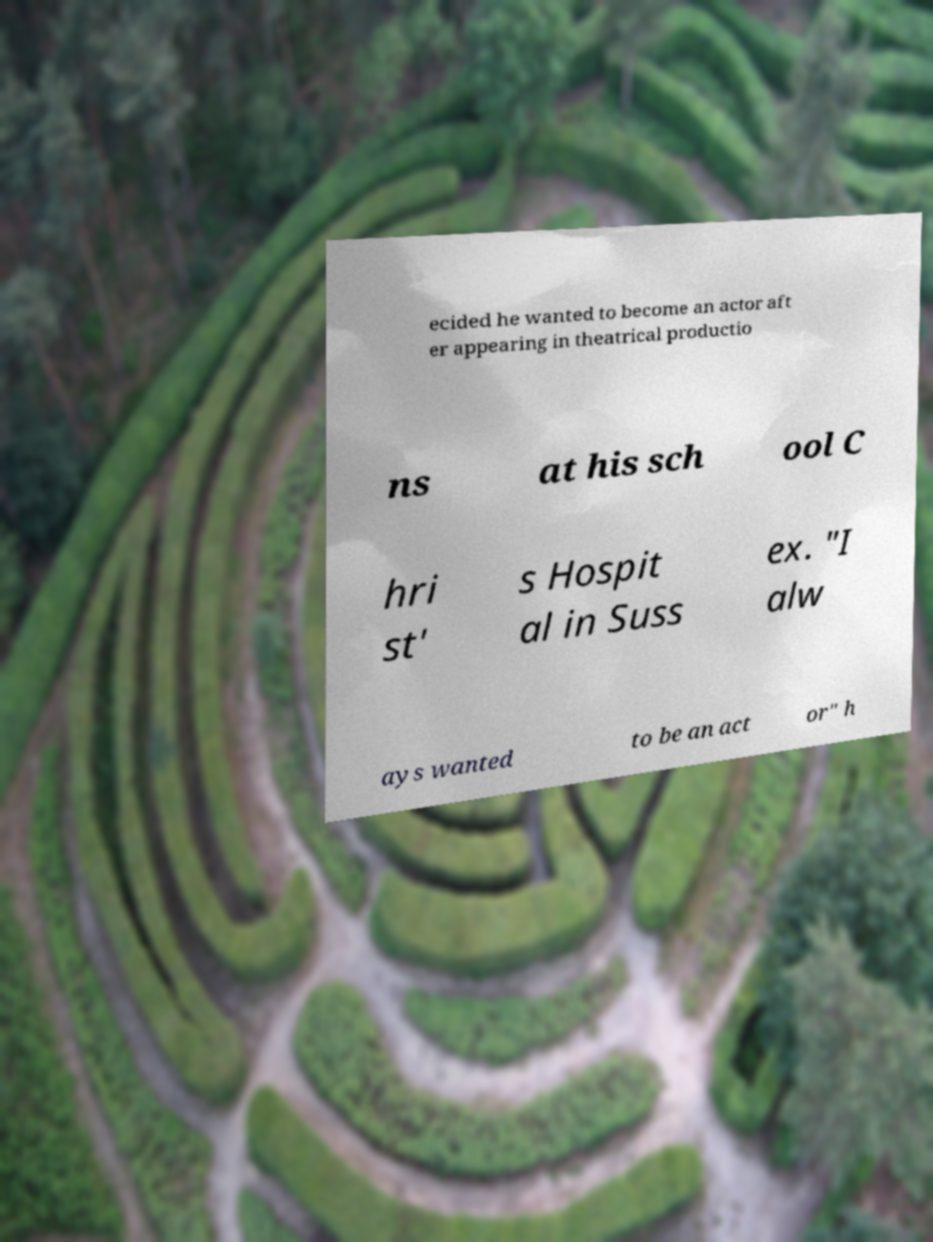Could you assist in decoding the text presented in this image and type it out clearly? ecided he wanted to become an actor aft er appearing in theatrical productio ns at his sch ool C hri st' s Hospit al in Suss ex. "I alw ays wanted to be an act or" h 